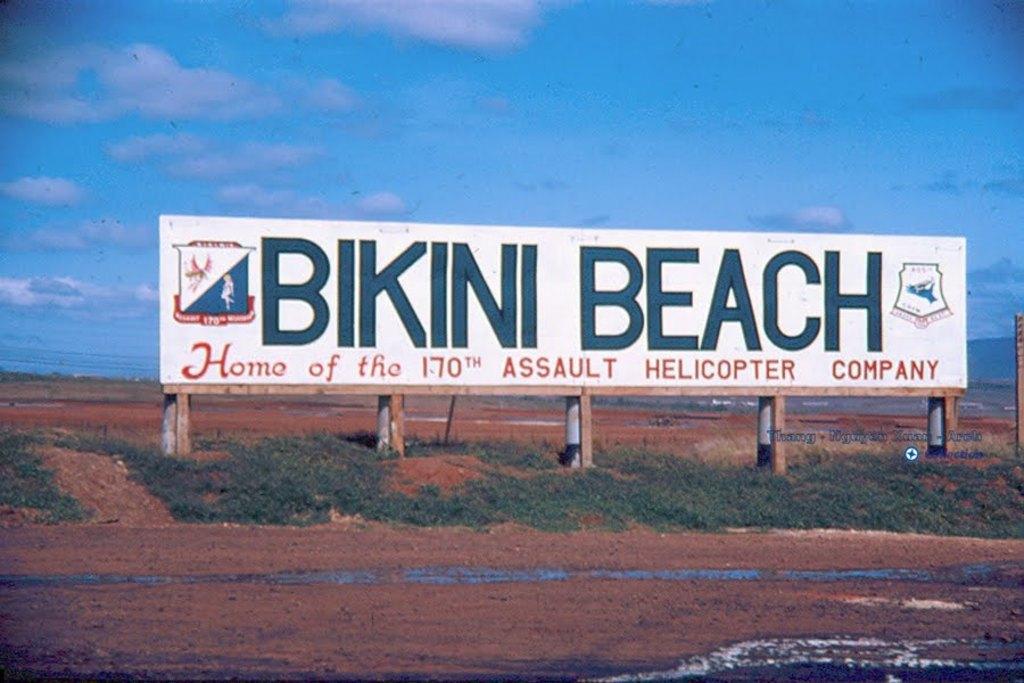Please provide a concise description of this image. In this picture we can see a board in the middle, there is some text on the board, at the bottom there is grass, soil and some water, there is the sky and clouds at the top of the picture. 